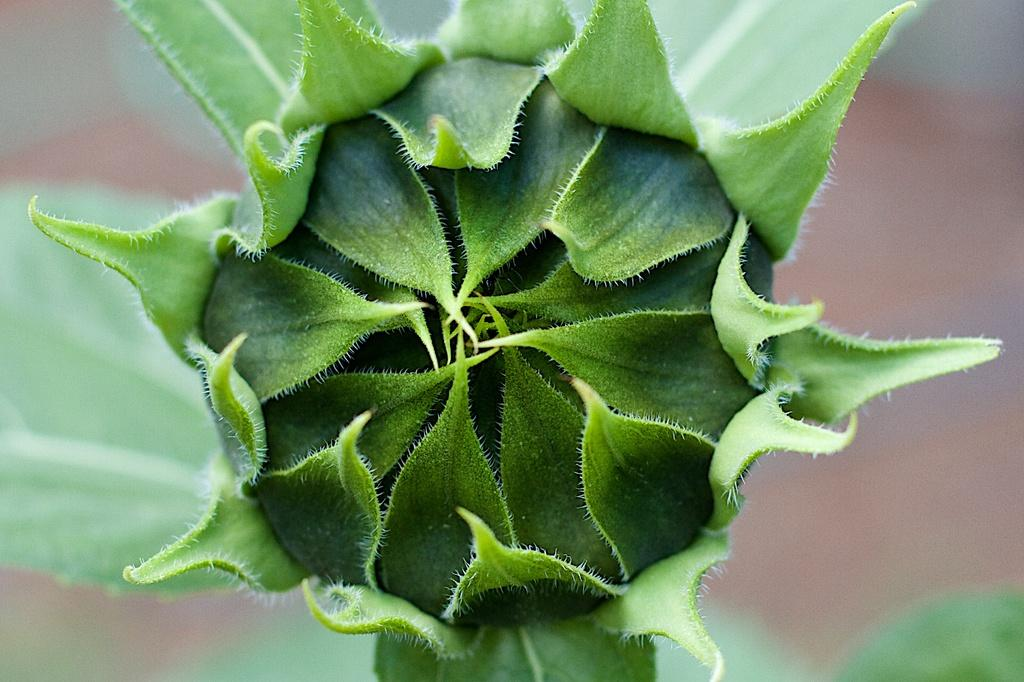What type of plant is in the image? There is a green color plant in the image. Can you describe any specific features of the plant? The plant has a bud. How is the bud positioned in relation to the plant? The bud is covered with leaves. What type of note is attached to the plant in the image? There is no note attached to the plant in the image. What material is the steel used for in the image? There is no steel present in the image. 